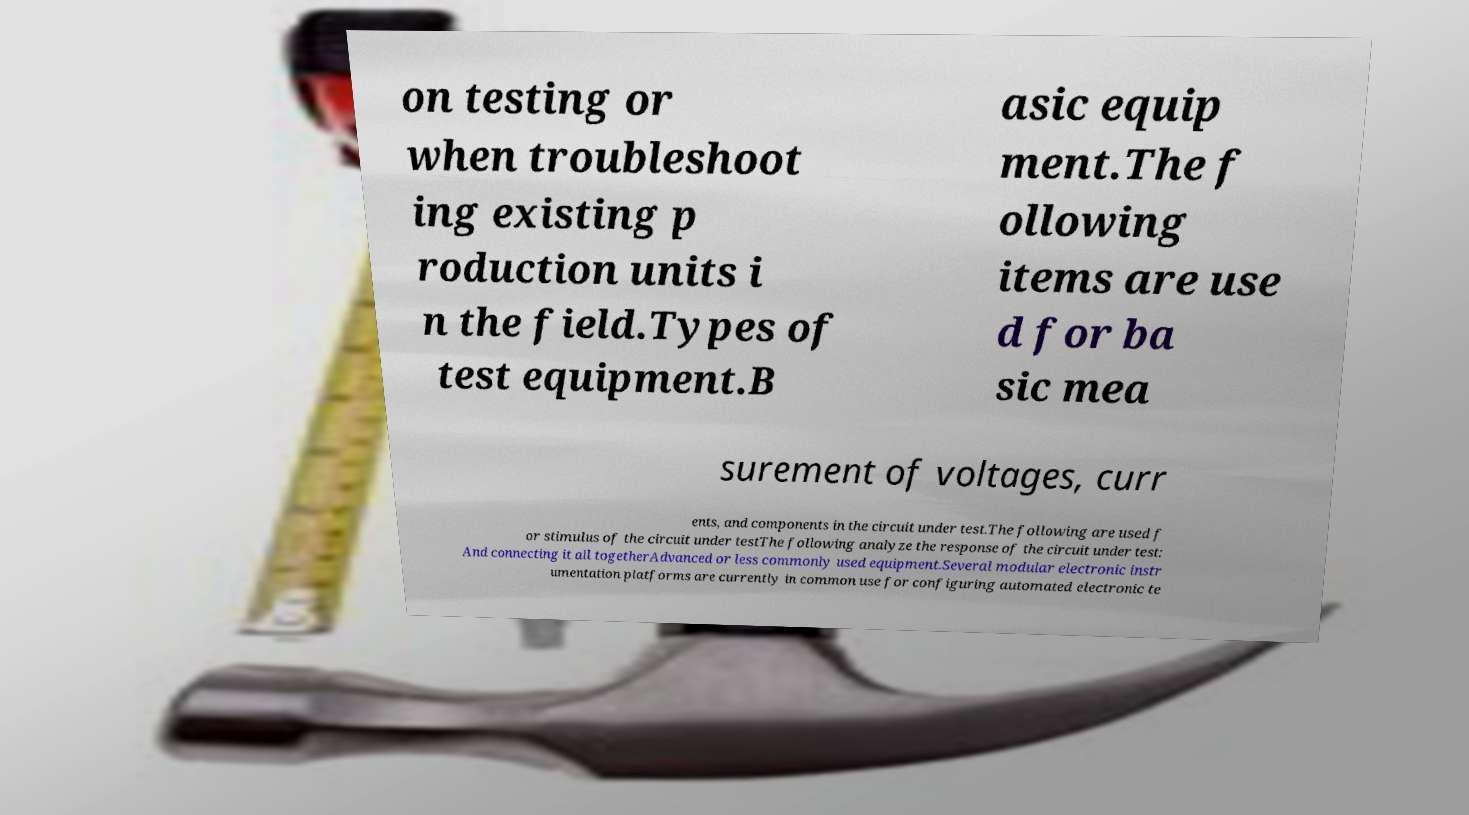For documentation purposes, I need the text within this image transcribed. Could you provide that? on testing or when troubleshoot ing existing p roduction units i n the field.Types of test equipment.B asic equip ment.The f ollowing items are use d for ba sic mea surement of voltages, curr ents, and components in the circuit under test.The following are used f or stimulus of the circuit under testThe following analyze the response of the circuit under test: And connecting it all togetherAdvanced or less commonly used equipment.Several modular electronic instr umentation platforms are currently in common use for configuring automated electronic te 